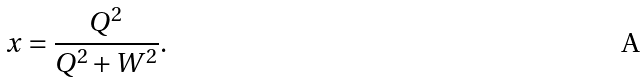Convert formula to latex. <formula><loc_0><loc_0><loc_500><loc_500>x = \frac { Q ^ { 2 } } { Q ^ { 2 } + W ^ { 2 } } .</formula> 